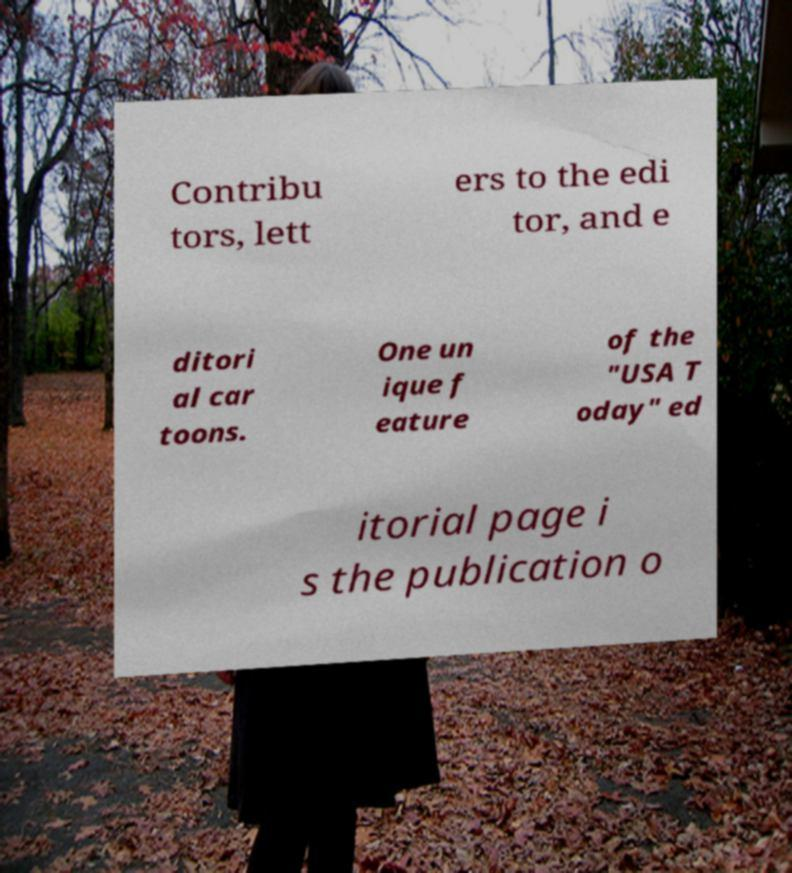Could you extract and type out the text from this image? Contribu tors, lett ers to the edi tor, and e ditori al car toons. One un ique f eature of the "USA T oday" ed itorial page i s the publication o 